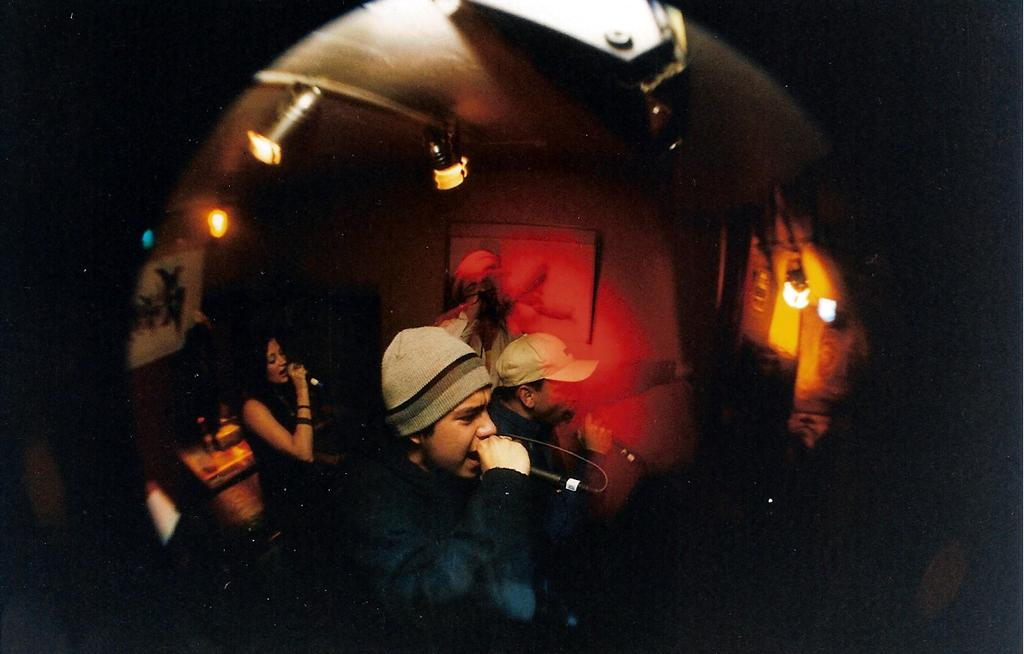What is the man in the image doing? The man is singing into a microphone. What is the man wearing in the image? The man is wearing a coat and a cap. Who else is in the image? There is a woman in the image. What is the woman doing in the image? The woman is also singing into a microphone. What can be seen at the top of the image? There are lights visible at the top of the image. What type of advertisement is being displayed on the rifle in the image? There is no rifle present in the image, and therefore no advertisement can be observed. 